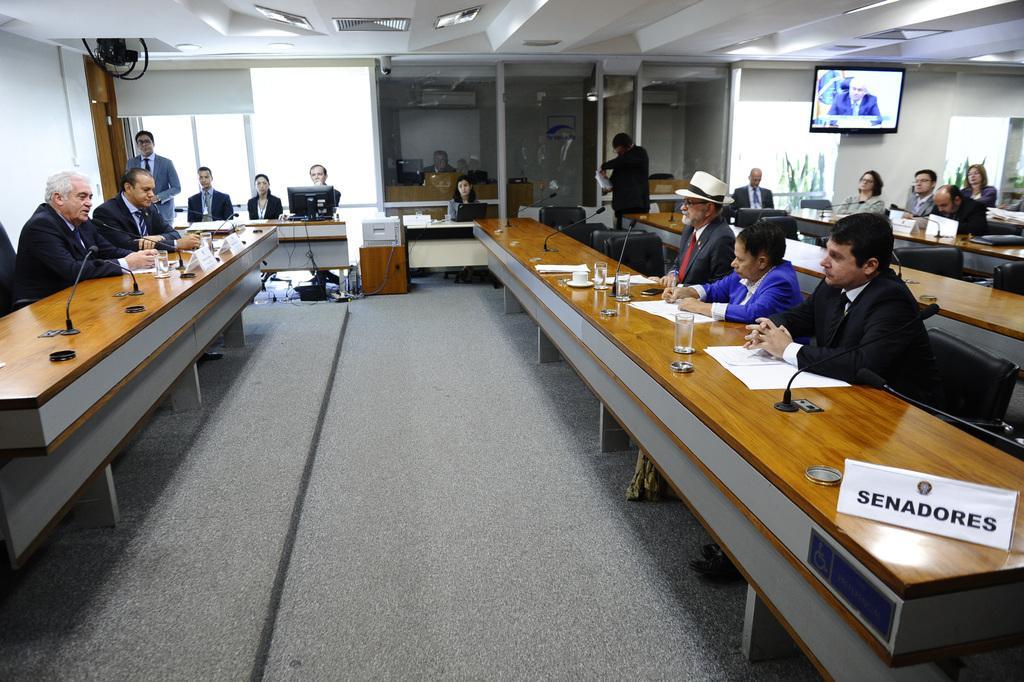Could you give a brief overview of what you see in this image? As we can see in the image there is a white color wall, screen, few people sitting on chairs and a table. On table there are glasses, mics and papers. 